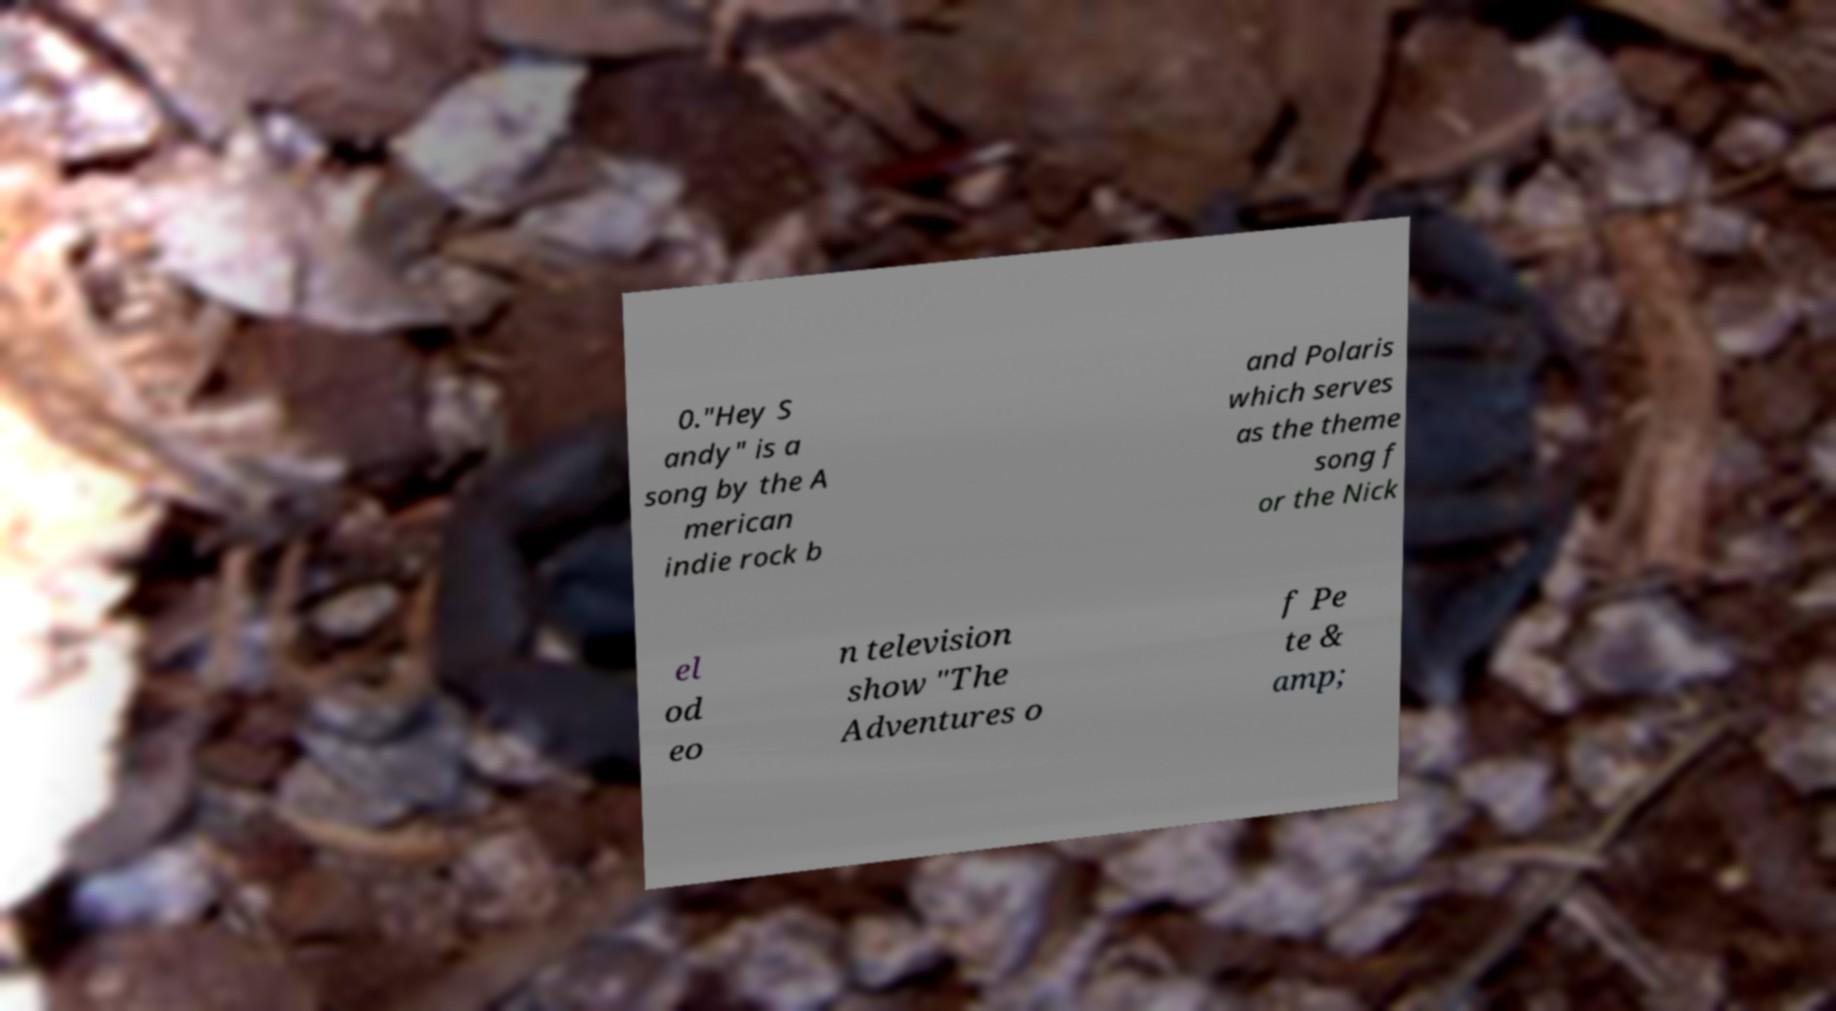I need the written content from this picture converted into text. Can you do that? 0."Hey S andy" is a song by the A merican indie rock b and Polaris which serves as the theme song f or the Nick el od eo n television show "The Adventures o f Pe te & amp; 